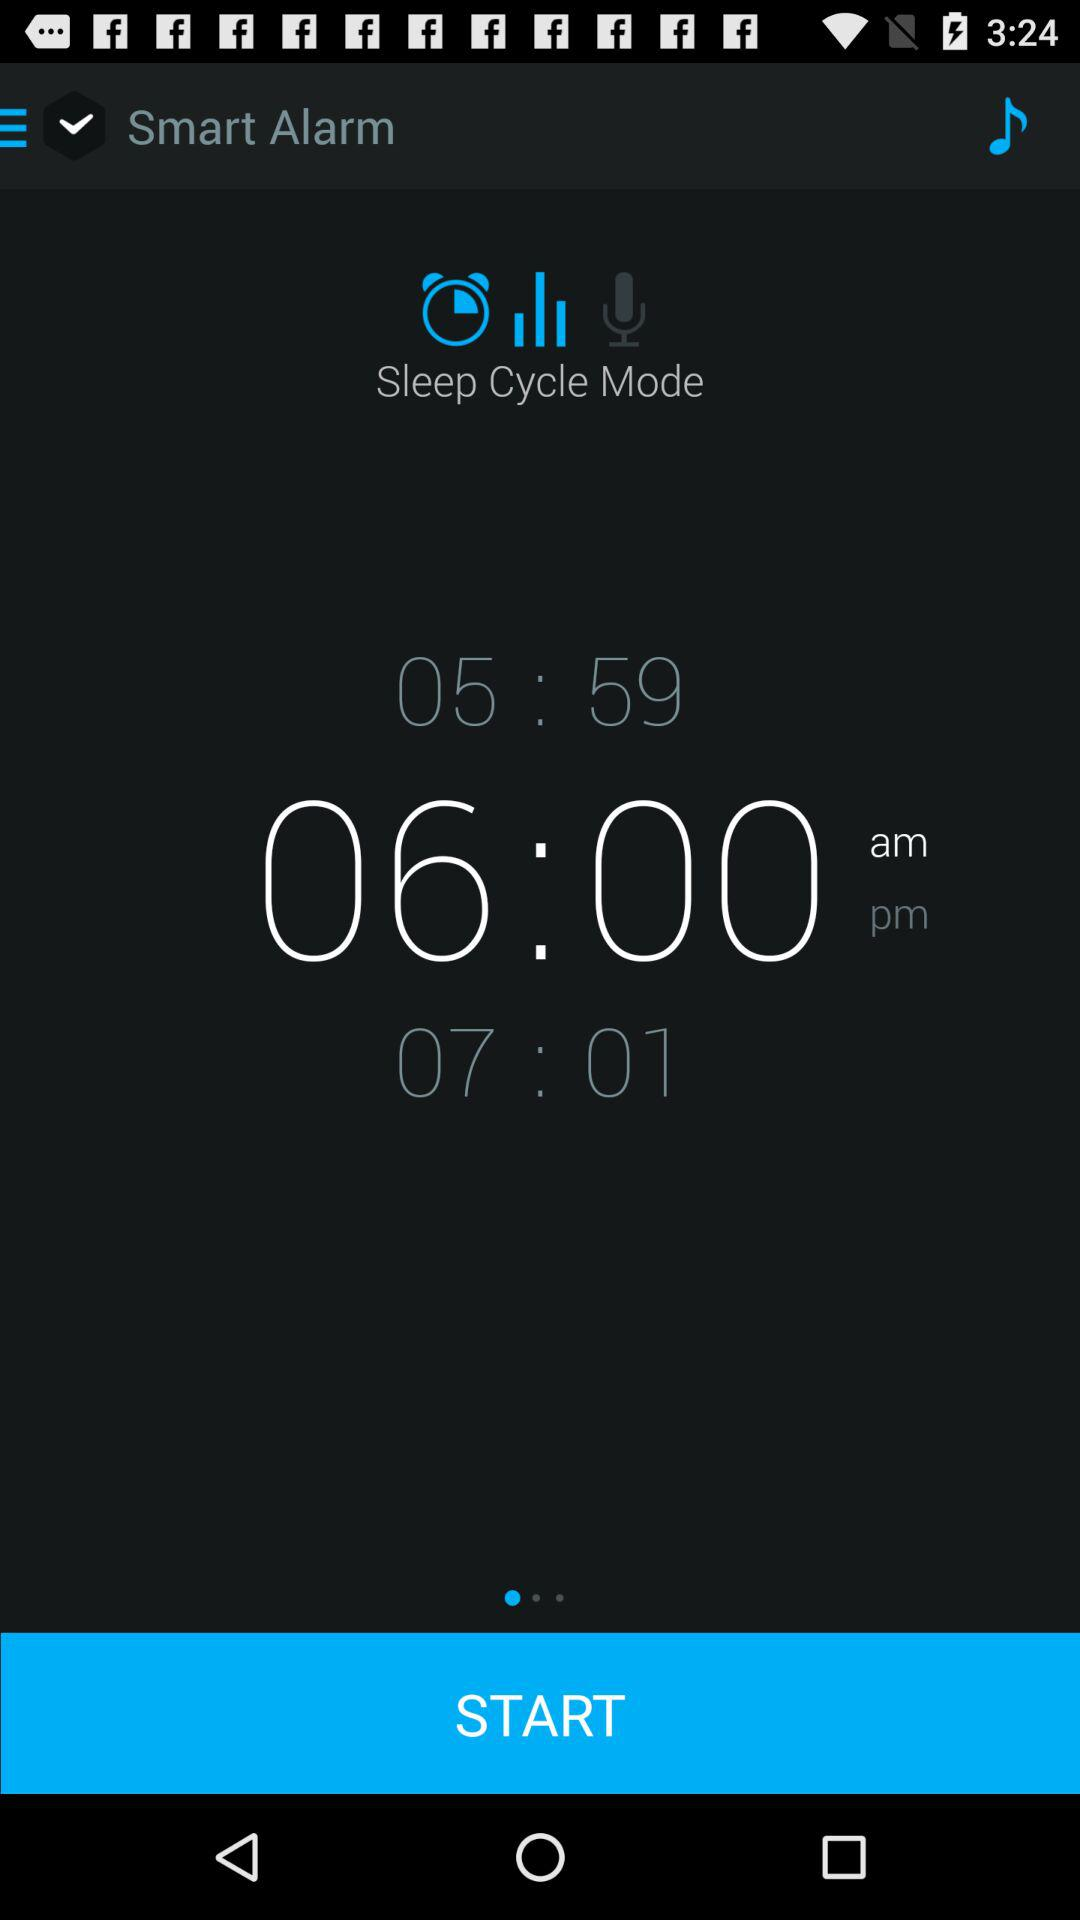What time is selected? The selected time is 6:00 a.m. 